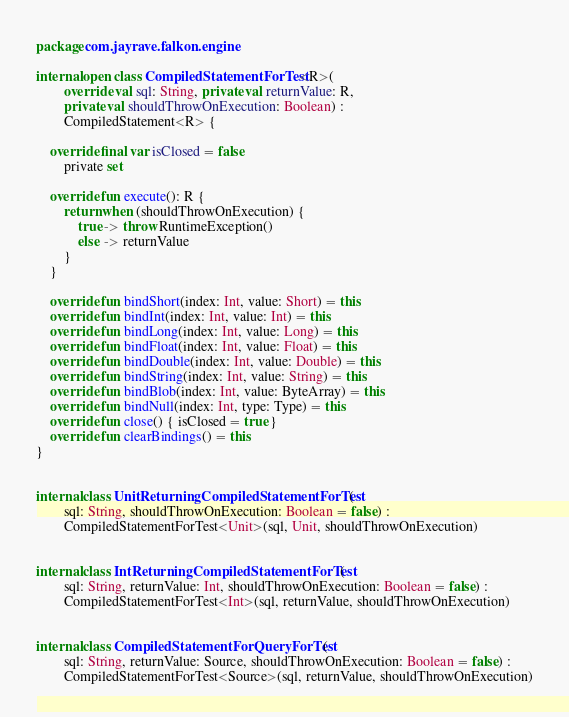<code> <loc_0><loc_0><loc_500><loc_500><_Kotlin_>package com.jayrave.falkon.engine

internal open class CompiledStatementForTest<R>(
        override val sql: String, private val returnValue: R,
        private val shouldThrowOnExecution: Boolean) :
        CompiledStatement<R> {

    override final var isClosed = false
        private set

    override fun execute(): R {
        return when (shouldThrowOnExecution) {
            true -> throw RuntimeException()
            else -> returnValue
        }
    }

    override fun bindShort(index: Int, value: Short) = this
    override fun bindInt(index: Int, value: Int) = this
    override fun bindLong(index: Int, value: Long) = this
    override fun bindFloat(index: Int, value: Float) = this
    override fun bindDouble(index: Int, value: Double) = this
    override fun bindString(index: Int, value: String) = this
    override fun bindBlob(index: Int, value: ByteArray) = this
    override fun bindNull(index: Int, type: Type) = this
    override fun close() { isClosed = true }
    override fun clearBindings() = this
}


internal class UnitReturningCompiledStatementForTest(
        sql: String, shouldThrowOnExecution: Boolean = false) :
        CompiledStatementForTest<Unit>(sql, Unit, shouldThrowOnExecution)


internal class IntReturningCompiledStatementForTest(
        sql: String, returnValue: Int, shouldThrowOnExecution: Boolean = false) :
        CompiledStatementForTest<Int>(sql, returnValue, shouldThrowOnExecution)


internal class CompiledStatementForQueryForTest(
        sql: String, returnValue: Source, shouldThrowOnExecution: Boolean = false) :
        CompiledStatementForTest<Source>(sql, returnValue, shouldThrowOnExecution)</code> 